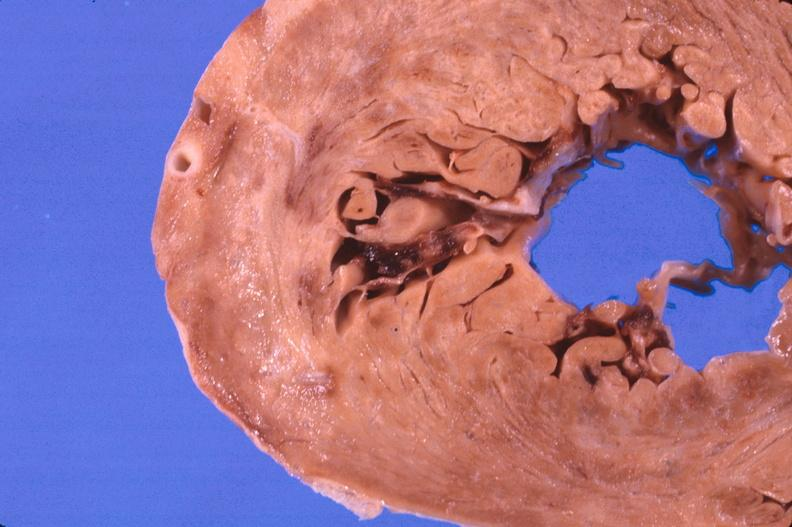s cardiovascular present?
Answer the question using a single word or phrase. Yes 